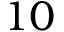<formula> <loc_0><loc_0><loc_500><loc_500>1 0</formula> 